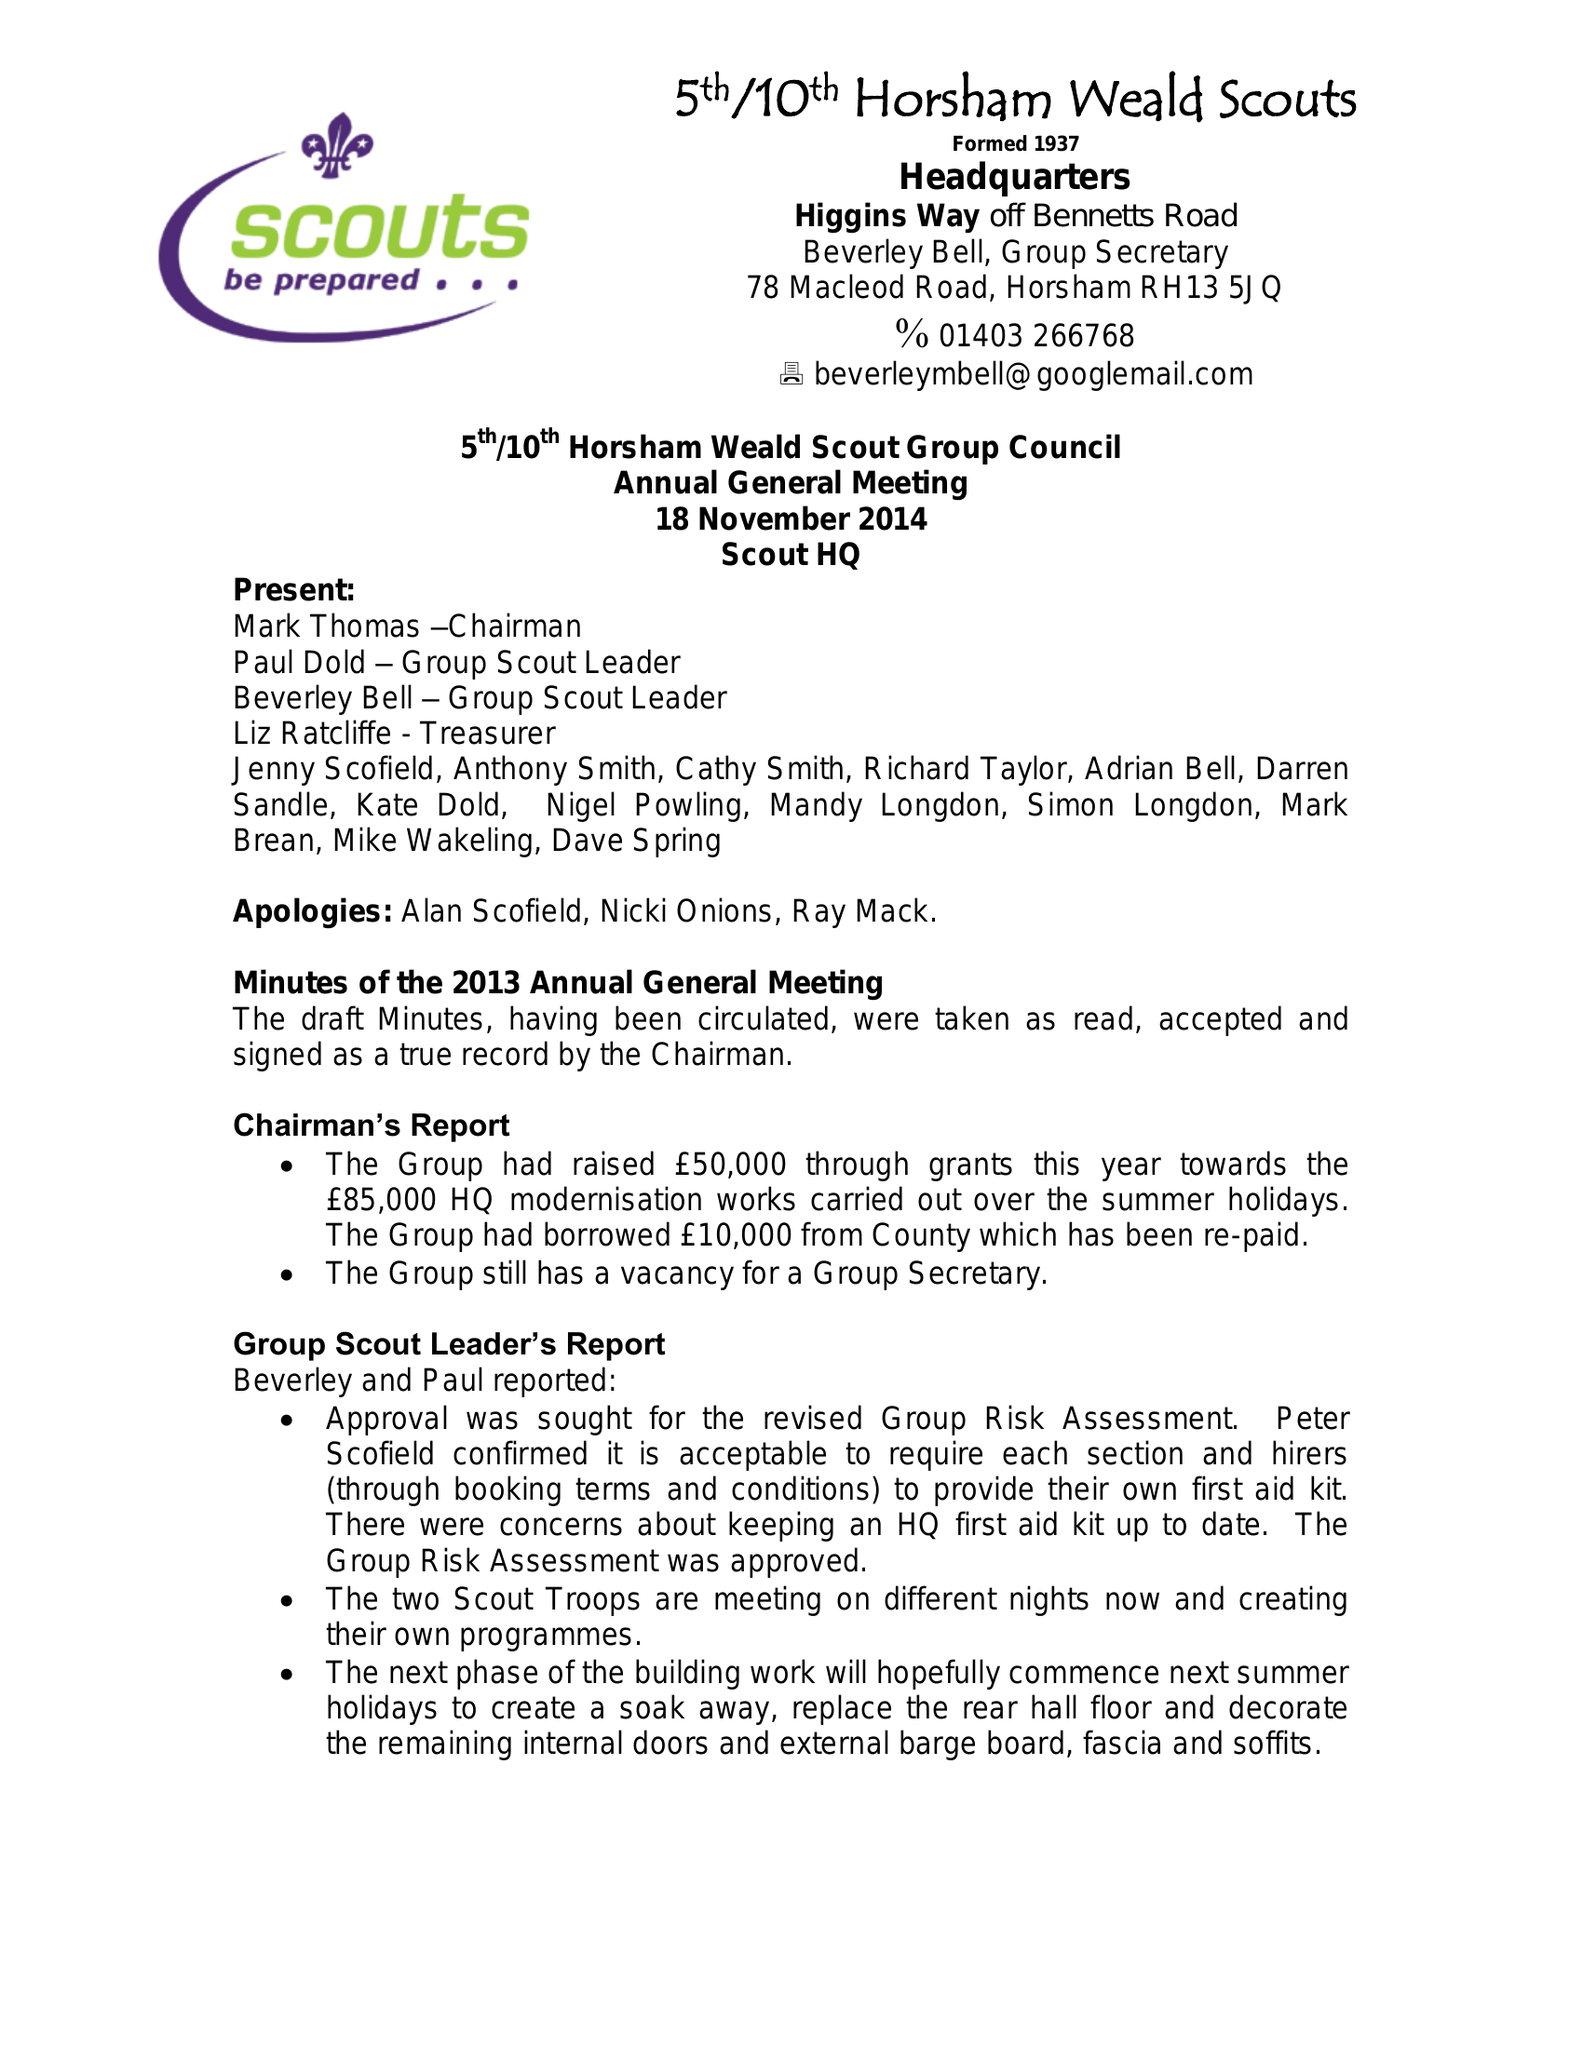What is the value for the charity_number?
Answer the question using a single word or phrase. 305891 